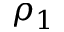Convert formula to latex. <formula><loc_0><loc_0><loc_500><loc_500>\rho _ { 1 }</formula> 